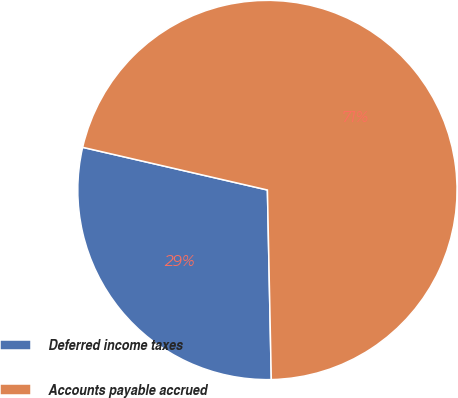<chart> <loc_0><loc_0><loc_500><loc_500><pie_chart><fcel>Deferred income taxes<fcel>Accounts payable accrued<nl><fcel>28.94%<fcel>71.06%<nl></chart> 